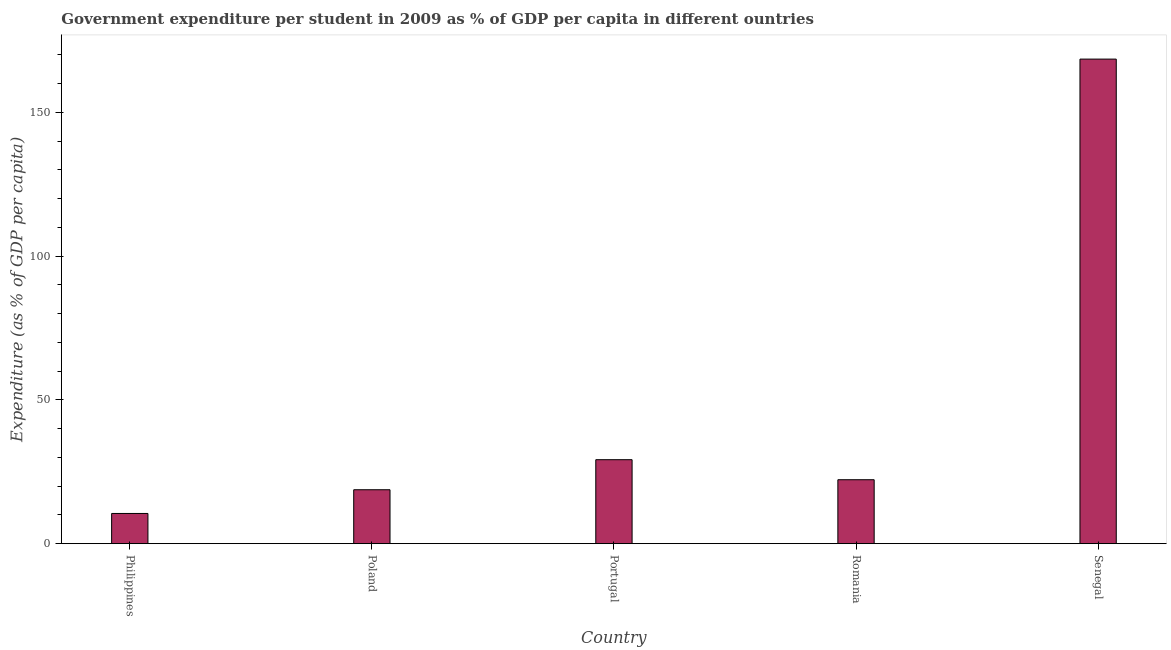What is the title of the graph?
Keep it short and to the point. Government expenditure per student in 2009 as % of GDP per capita in different ountries. What is the label or title of the Y-axis?
Your answer should be compact. Expenditure (as % of GDP per capita). What is the government expenditure per student in Poland?
Give a very brief answer. 18.75. Across all countries, what is the maximum government expenditure per student?
Provide a succinct answer. 168.54. Across all countries, what is the minimum government expenditure per student?
Offer a terse response. 10.51. In which country was the government expenditure per student maximum?
Provide a short and direct response. Senegal. What is the sum of the government expenditure per student?
Keep it short and to the point. 249.24. What is the difference between the government expenditure per student in Portugal and Senegal?
Provide a short and direct response. -139.34. What is the average government expenditure per student per country?
Make the answer very short. 49.85. What is the median government expenditure per student?
Give a very brief answer. 22.24. What is the ratio of the government expenditure per student in Poland to that in Romania?
Offer a very short reply. 0.84. Is the government expenditure per student in Poland less than that in Romania?
Ensure brevity in your answer.  Yes. Is the difference between the government expenditure per student in Poland and Portugal greater than the difference between any two countries?
Give a very brief answer. No. What is the difference between the highest and the second highest government expenditure per student?
Your response must be concise. 139.34. What is the difference between the highest and the lowest government expenditure per student?
Ensure brevity in your answer.  158.04. How many bars are there?
Give a very brief answer. 5. Are all the bars in the graph horizontal?
Provide a short and direct response. No. Are the values on the major ticks of Y-axis written in scientific E-notation?
Provide a succinct answer. No. What is the Expenditure (as % of GDP per capita) in Philippines?
Provide a succinct answer. 10.51. What is the Expenditure (as % of GDP per capita) of Poland?
Ensure brevity in your answer.  18.75. What is the Expenditure (as % of GDP per capita) in Portugal?
Your response must be concise. 29.2. What is the Expenditure (as % of GDP per capita) of Romania?
Provide a succinct answer. 22.24. What is the Expenditure (as % of GDP per capita) of Senegal?
Provide a succinct answer. 168.54. What is the difference between the Expenditure (as % of GDP per capita) in Philippines and Poland?
Ensure brevity in your answer.  -8.25. What is the difference between the Expenditure (as % of GDP per capita) in Philippines and Portugal?
Ensure brevity in your answer.  -18.7. What is the difference between the Expenditure (as % of GDP per capita) in Philippines and Romania?
Your answer should be very brief. -11.73. What is the difference between the Expenditure (as % of GDP per capita) in Philippines and Senegal?
Offer a very short reply. -158.04. What is the difference between the Expenditure (as % of GDP per capita) in Poland and Portugal?
Provide a short and direct response. -10.45. What is the difference between the Expenditure (as % of GDP per capita) in Poland and Romania?
Your answer should be compact. -3.49. What is the difference between the Expenditure (as % of GDP per capita) in Poland and Senegal?
Your answer should be very brief. -149.79. What is the difference between the Expenditure (as % of GDP per capita) in Portugal and Romania?
Your response must be concise. 6.96. What is the difference between the Expenditure (as % of GDP per capita) in Portugal and Senegal?
Ensure brevity in your answer.  -139.34. What is the difference between the Expenditure (as % of GDP per capita) in Romania and Senegal?
Ensure brevity in your answer.  -146.3. What is the ratio of the Expenditure (as % of GDP per capita) in Philippines to that in Poland?
Your answer should be very brief. 0.56. What is the ratio of the Expenditure (as % of GDP per capita) in Philippines to that in Portugal?
Ensure brevity in your answer.  0.36. What is the ratio of the Expenditure (as % of GDP per capita) in Philippines to that in Romania?
Provide a short and direct response. 0.47. What is the ratio of the Expenditure (as % of GDP per capita) in Philippines to that in Senegal?
Your answer should be very brief. 0.06. What is the ratio of the Expenditure (as % of GDP per capita) in Poland to that in Portugal?
Your answer should be compact. 0.64. What is the ratio of the Expenditure (as % of GDP per capita) in Poland to that in Romania?
Give a very brief answer. 0.84. What is the ratio of the Expenditure (as % of GDP per capita) in Poland to that in Senegal?
Offer a terse response. 0.11. What is the ratio of the Expenditure (as % of GDP per capita) in Portugal to that in Romania?
Offer a terse response. 1.31. What is the ratio of the Expenditure (as % of GDP per capita) in Portugal to that in Senegal?
Give a very brief answer. 0.17. What is the ratio of the Expenditure (as % of GDP per capita) in Romania to that in Senegal?
Keep it short and to the point. 0.13. 